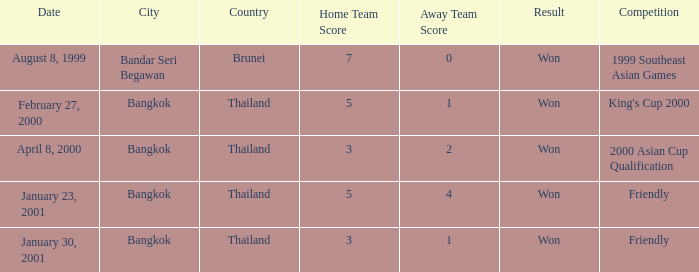What was the result from the 2000 asian cup qualification? Won. 